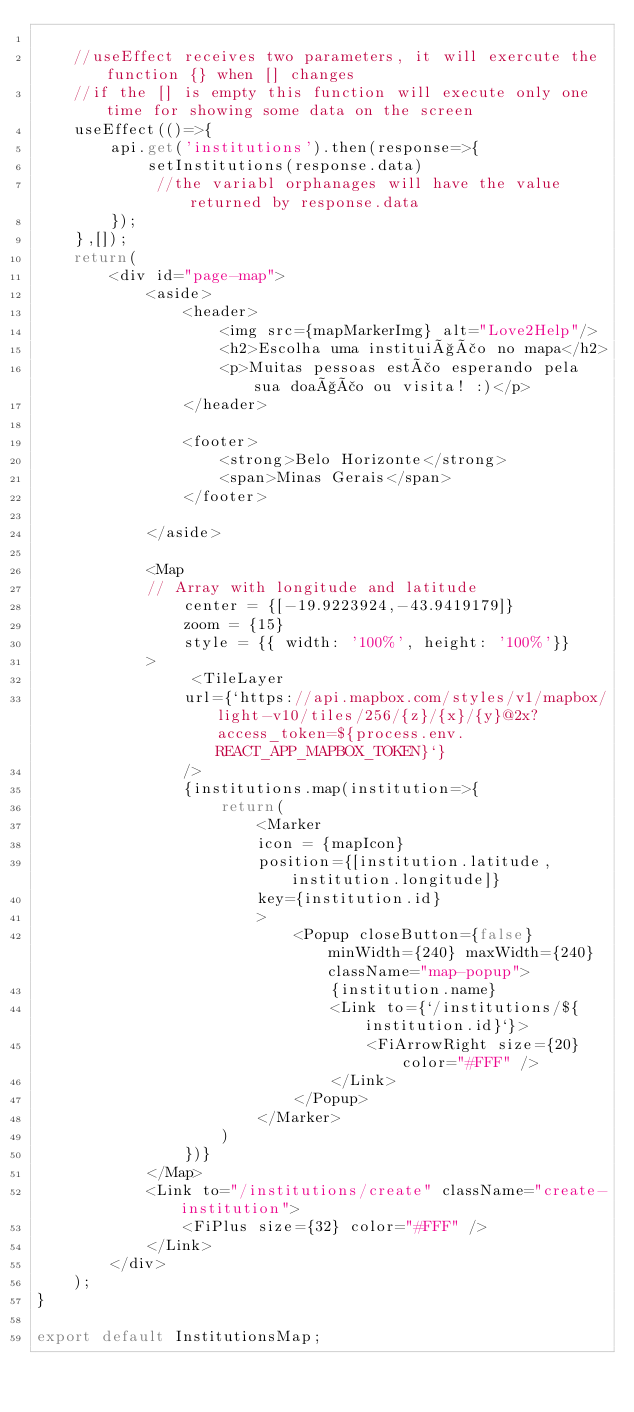Convert code to text. <code><loc_0><loc_0><loc_500><loc_500><_TypeScript_>
    //useEffect receives two parameters, it will exercute the function {} when [] changes
    //if the [] is empty this function will execute only one time for showing some data on the screen
    useEffect(()=>{
        api.get('institutions').then(response=>{
            setInstitutions(response.data)
             //the variabl orphanages will have the value returned by response.data 
        });
    },[]);
    return(
        <div id="page-map">
            <aside>
                <header>
                    <img src={mapMarkerImg} alt="Love2Help"/>
                    <h2>Escolha uma instituição no mapa</h2>
                    <p>Muitas pessoas estão esperando pela sua doação ou visita! :)</p>
                </header>

                <footer>
                    <strong>Belo Horizonte</strong>
                    <span>Minas Gerais</span>
                </footer>

            </aside>

            <Map
            // Array with longitude and latitude
                center = {[-19.9223924,-43.9419179]}
                zoom = {15}
                style = {{ width: '100%', height: '100%'}}
            >
                 <TileLayer 
                url={`https://api.mapbox.com/styles/v1/mapbox/light-v10/tiles/256/{z}/{x}/{y}@2x?access_token=${process.env.REACT_APP_MAPBOX_TOKEN}`} 
                />
                {institutions.map(institution=>{
                    return(
                        <Marker
                        icon = {mapIcon}
                        position={[institution.latitude, institution.longitude]}
                        key={institution.id}
                        >
                            <Popup closeButton={false} minWidth={240} maxWidth={240} className="map-popup">
                                {institution.name}
                                <Link to={`/institutions/${institution.id}`}>
                                    <FiArrowRight size={20} color="#FFF" />
                                </Link>
                            </Popup>
                        </Marker>
                    )
                })}
            </Map>
            <Link to="/institutions/create" className="create-institution">
                <FiPlus size={32} color="#FFF" />
            </Link>
        </div>
    );
}

export default InstitutionsMap;</code> 